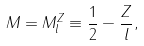Convert formula to latex. <formula><loc_0><loc_0><loc_500><loc_500>M = M _ { l } ^ { Z } \equiv \frac { 1 } { 2 } - \frac { Z } { l } ,</formula> 